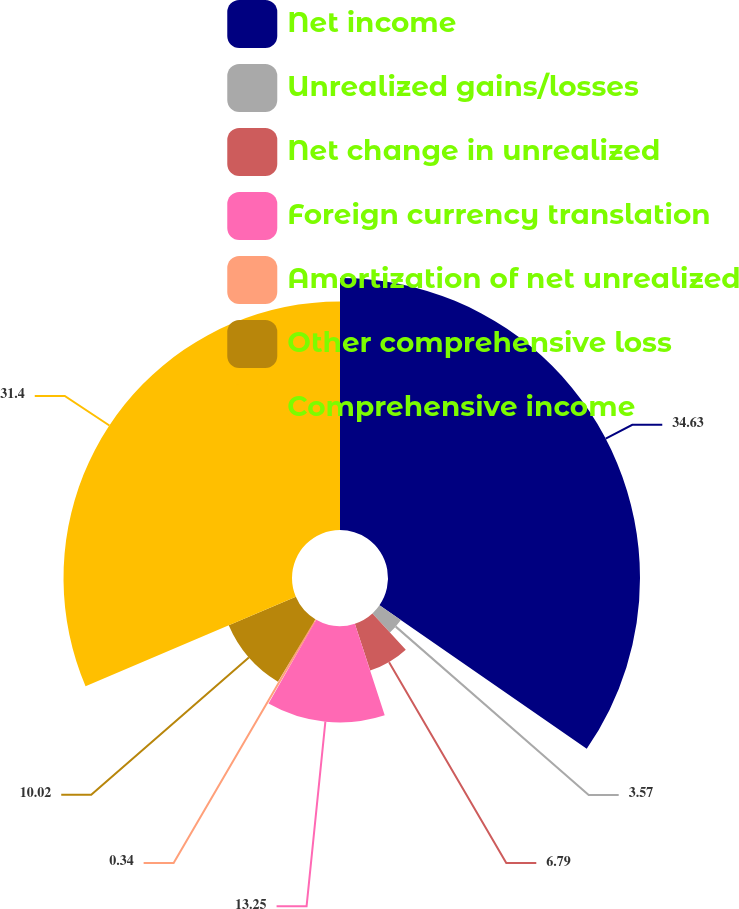Convert chart. <chart><loc_0><loc_0><loc_500><loc_500><pie_chart><fcel>Net income<fcel>Unrealized gains/losses<fcel>Net change in unrealized<fcel>Foreign currency translation<fcel>Amortization of net unrealized<fcel>Other comprehensive loss<fcel>Comprehensive income<nl><fcel>34.63%<fcel>3.57%<fcel>6.79%<fcel>13.25%<fcel>0.34%<fcel>10.02%<fcel>31.4%<nl></chart> 